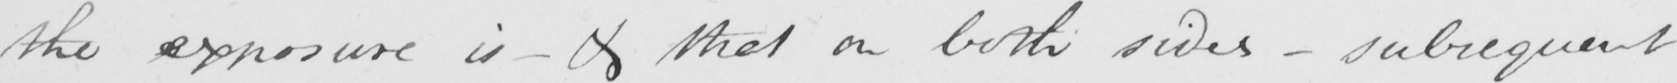Can you tell me what this handwritten text says? the exposure is  _  & that on both sides  _  subsequent 